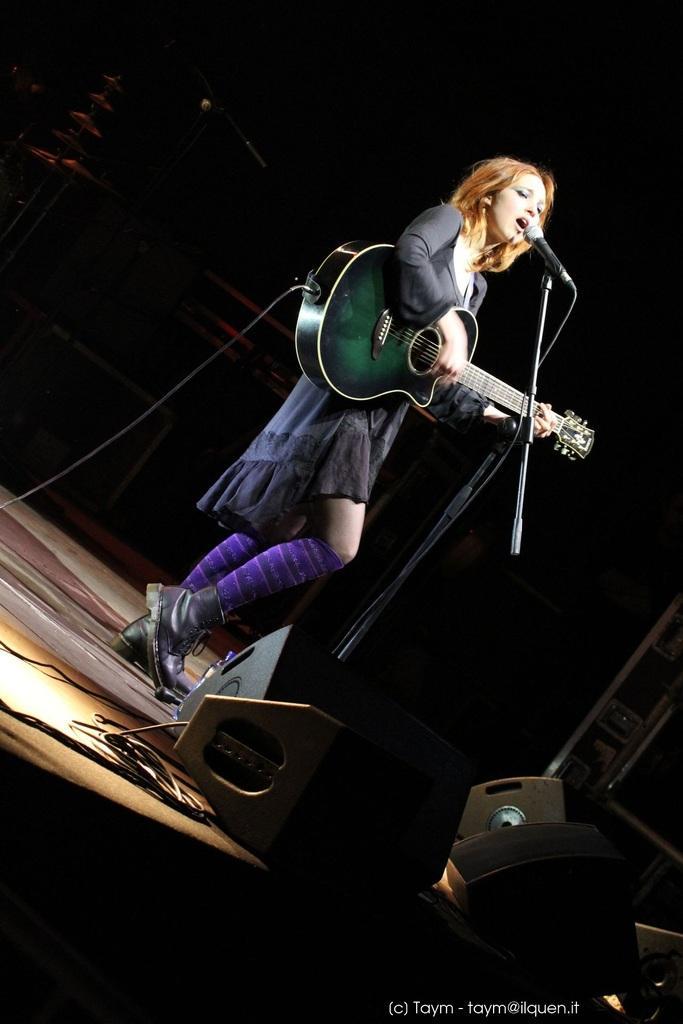Could you give a brief overview of what you see in this image? This image is clicked in a musical concert. There are wires in the bottom, there is a woman standing in the middle, she is playing guitar and mike is in front of her. she is singing something. Behind her on the top left corner there are drums and there is Mike placed in front of the drums. There are speakers in the bottom. 